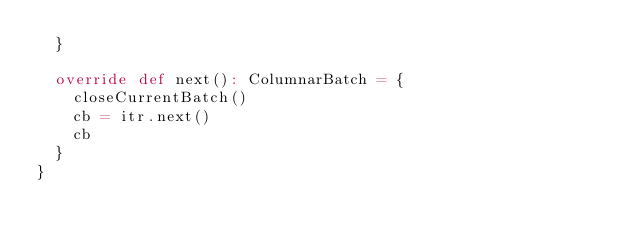<code> <loc_0><loc_0><loc_500><loc_500><_Scala_>  }

  override def next(): ColumnarBatch = {
    closeCurrentBatch()
    cb = itr.next()
    cb
  }
}
</code> 